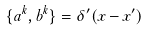Convert formula to latex. <formula><loc_0><loc_0><loc_500><loc_500>\{ a ^ { k } , b ^ { k } \} = \delta ^ { \prime } ( x - x ^ { \prime } )</formula> 